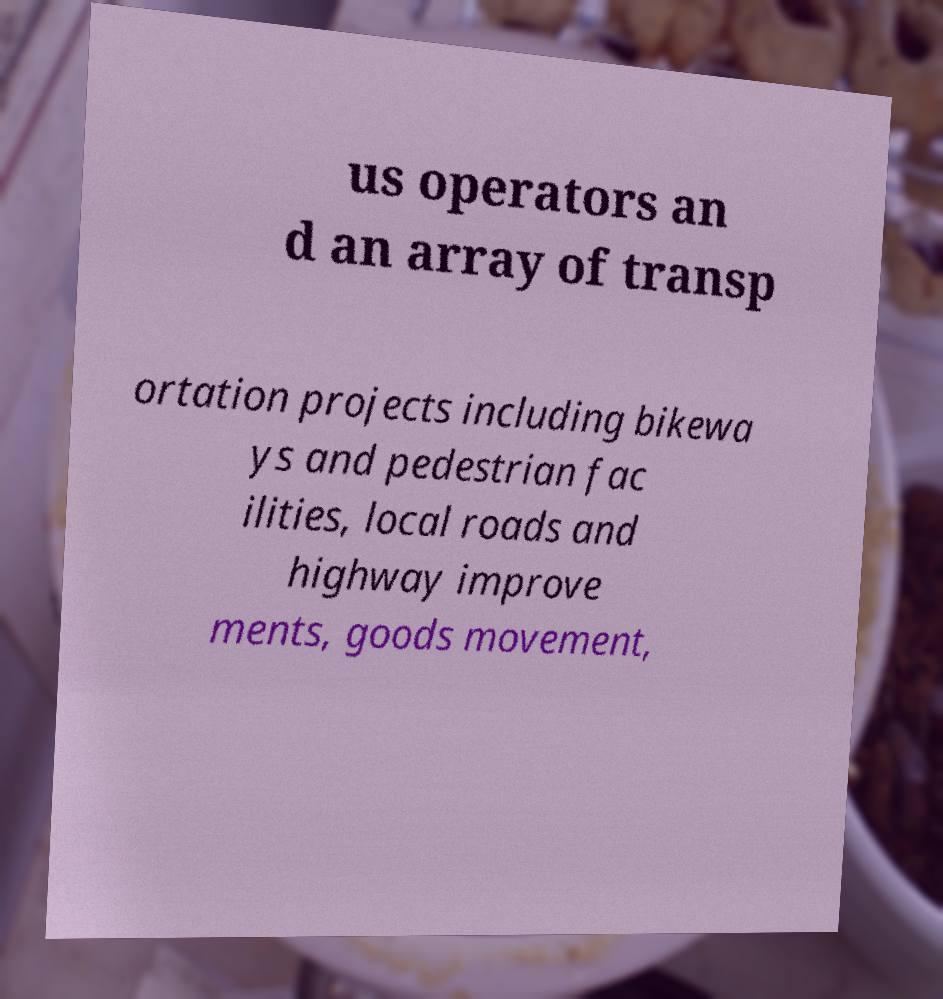For documentation purposes, I need the text within this image transcribed. Could you provide that? us operators an d an array of transp ortation projects including bikewa ys and pedestrian fac ilities, local roads and highway improve ments, goods movement, 